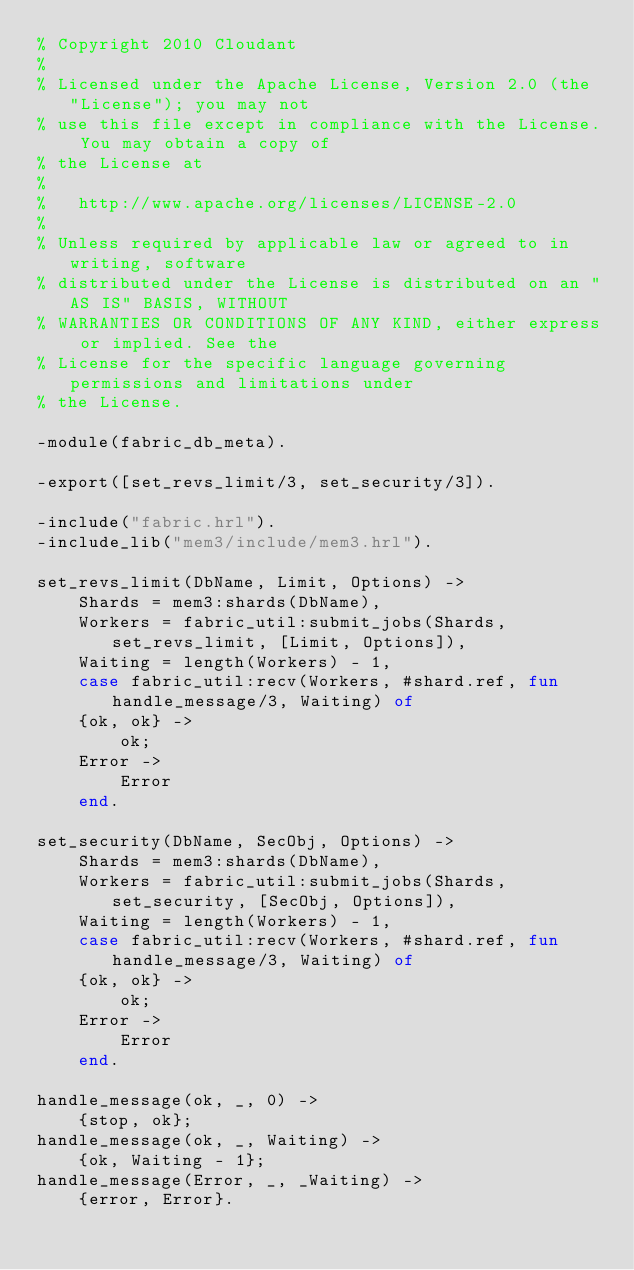<code> <loc_0><loc_0><loc_500><loc_500><_Erlang_>% Copyright 2010 Cloudant
%
% Licensed under the Apache License, Version 2.0 (the "License"); you may not
% use this file except in compliance with the License. You may obtain a copy of
% the License at
%
%   http://www.apache.org/licenses/LICENSE-2.0
%
% Unless required by applicable law or agreed to in writing, software
% distributed under the License is distributed on an "AS IS" BASIS, WITHOUT
% WARRANTIES OR CONDITIONS OF ANY KIND, either express or implied. See the
% License for the specific language governing permissions and limitations under
% the License.

-module(fabric_db_meta).

-export([set_revs_limit/3, set_security/3]).

-include("fabric.hrl").
-include_lib("mem3/include/mem3.hrl").

set_revs_limit(DbName, Limit, Options) ->
    Shards = mem3:shards(DbName),
    Workers = fabric_util:submit_jobs(Shards, set_revs_limit, [Limit, Options]),
    Waiting = length(Workers) - 1,
    case fabric_util:recv(Workers, #shard.ref, fun handle_message/3, Waiting) of
    {ok, ok} ->
        ok;
    Error ->
        Error
    end.

set_security(DbName, SecObj, Options) ->
    Shards = mem3:shards(DbName),
    Workers = fabric_util:submit_jobs(Shards, set_security, [SecObj, Options]),
    Waiting = length(Workers) - 1,
    case fabric_util:recv(Workers, #shard.ref, fun handle_message/3, Waiting) of
    {ok, ok} ->
        ok;
    Error ->
        Error
    end.

handle_message(ok, _, 0) ->
    {stop, ok};
handle_message(ok, _, Waiting) ->
    {ok, Waiting - 1};
handle_message(Error, _, _Waiting) ->
    {error, Error}.</code> 